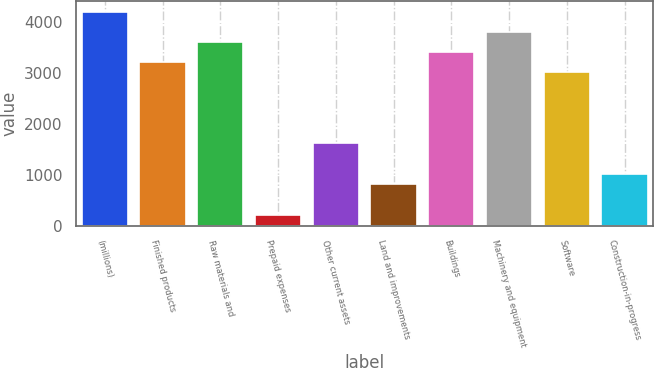Convert chart to OTSL. <chart><loc_0><loc_0><loc_500><loc_500><bar_chart><fcel>(millions)<fcel>Finished products<fcel>Raw materials and<fcel>Prepaid expenses<fcel>Other current assets<fcel>Land and improvements<fcel>Buildings<fcel>Machinery and equipment<fcel>Software<fcel>Construction-in-progress<nl><fcel>4210.37<fcel>3212.02<fcel>3611.36<fcel>216.97<fcel>1614.66<fcel>815.98<fcel>3411.69<fcel>3811.03<fcel>3012.35<fcel>1015.65<nl></chart> 